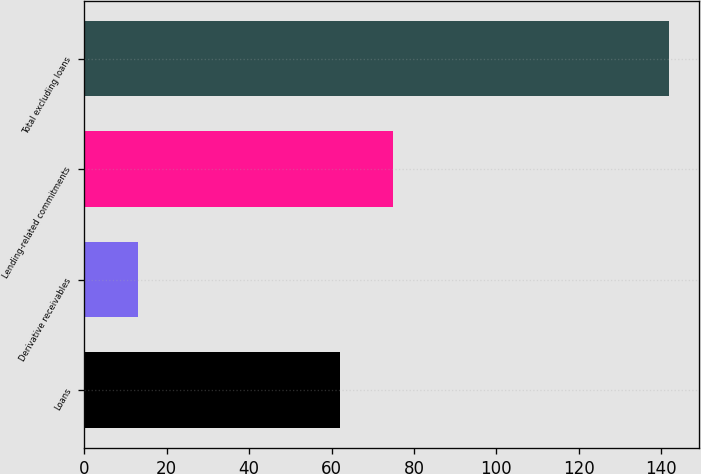Convert chart. <chart><loc_0><loc_0><loc_500><loc_500><bar_chart><fcel>Loans<fcel>Derivative receivables<fcel>Lending-related commitments<fcel>Total excluding loans<nl><fcel>62<fcel>13<fcel>74.9<fcel>142<nl></chart> 